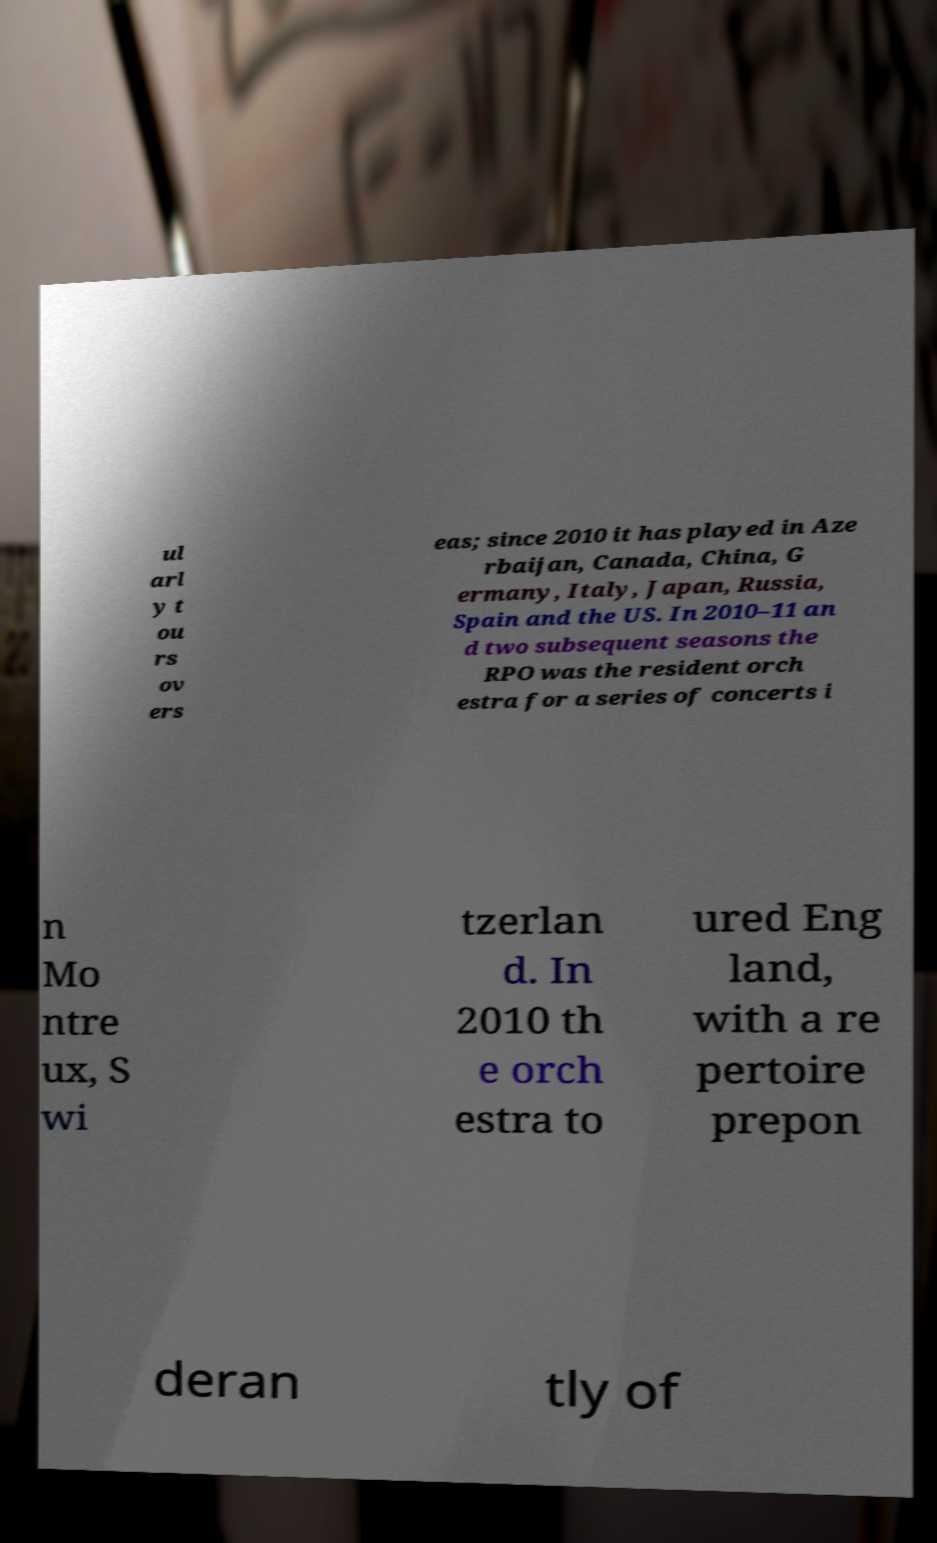There's text embedded in this image that I need extracted. Can you transcribe it verbatim? ul arl y t ou rs ov ers eas; since 2010 it has played in Aze rbaijan, Canada, China, G ermany, Italy, Japan, Russia, Spain and the US. In 2010–11 an d two subsequent seasons the RPO was the resident orch estra for a series of concerts i n Mo ntre ux, S wi tzerlan d. In 2010 th e orch estra to ured Eng land, with a re pertoire prepon deran tly of 